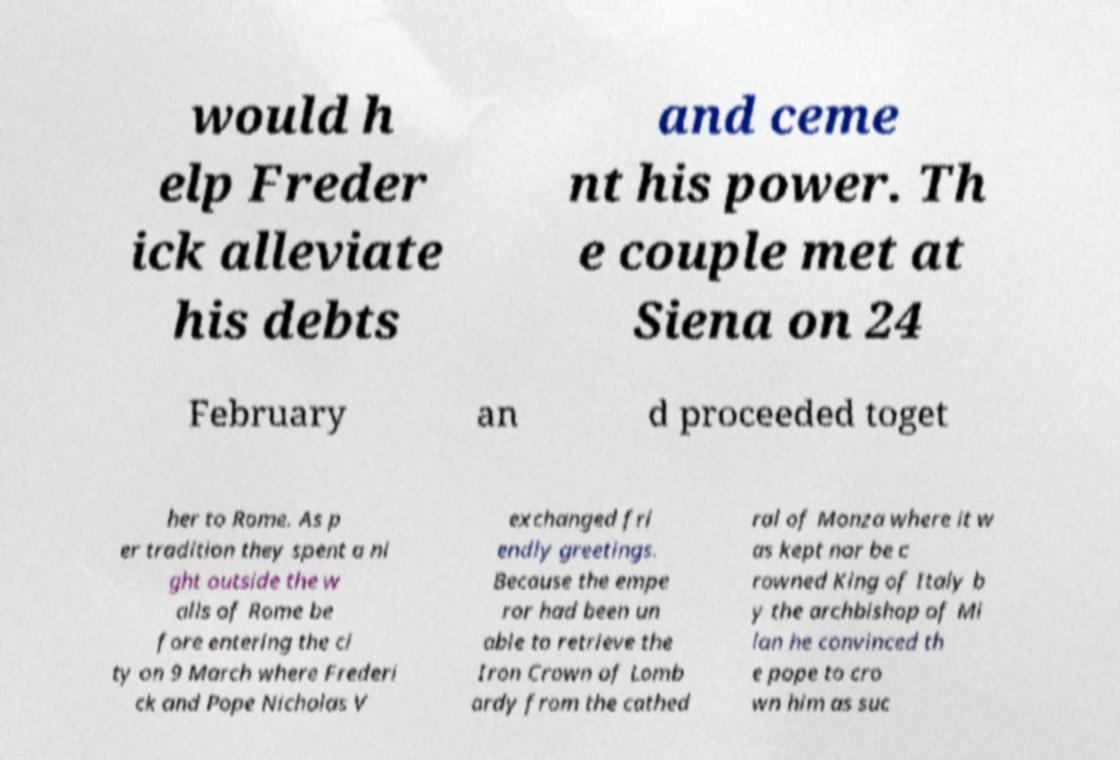Can you read and provide the text displayed in the image?This photo seems to have some interesting text. Can you extract and type it out for me? would h elp Freder ick alleviate his debts and ceme nt his power. Th e couple met at Siena on 24 February an d proceeded toget her to Rome. As p er tradition they spent a ni ght outside the w alls of Rome be fore entering the ci ty on 9 March where Frederi ck and Pope Nicholas V exchanged fri endly greetings. Because the empe ror had been un able to retrieve the Iron Crown of Lomb ardy from the cathed ral of Monza where it w as kept nor be c rowned King of Italy b y the archbishop of Mi lan he convinced th e pope to cro wn him as suc 